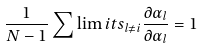<formula> <loc_0><loc_0><loc_500><loc_500>\frac { 1 } { N - 1 } \sum \lim i t s _ { l \neq i } \frac { \partial \alpha _ { l } } { \partial \alpha _ { l } } = 1</formula> 